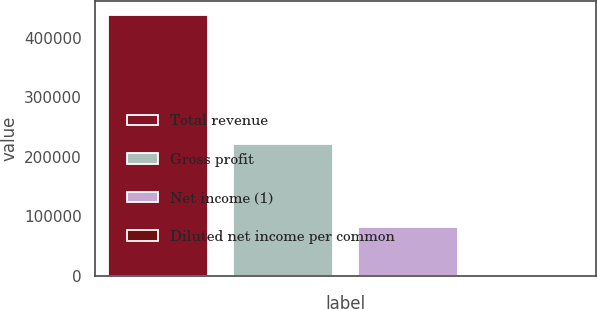Convert chart to OTSL. <chart><loc_0><loc_0><loc_500><loc_500><bar_chart><fcel>Total revenue<fcel>Gross profit<fcel>Net income (1)<fcel>Diluted net income per common<nl><fcel>438651<fcel>220687<fcel>82445<fcel>0.31<nl></chart> 